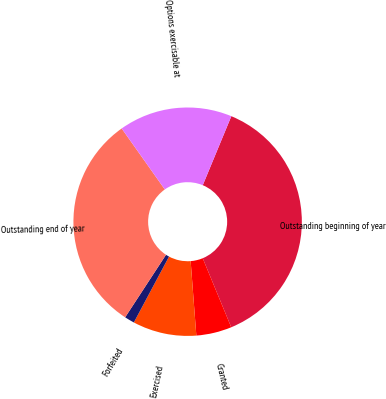Convert chart. <chart><loc_0><loc_0><loc_500><loc_500><pie_chart><fcel>Outstanding beginning of year<fcel>Granted<fcel>Exercised<fcel>Forfeited<fcel>Outstanding end of year<fcel>Options exercisable at<nl><fcel>37.52%<fcel>5.02%<fcel>9.02%<fcel>1.41%<fcel>30.99%<fcel>16.05%<nl></chart> 